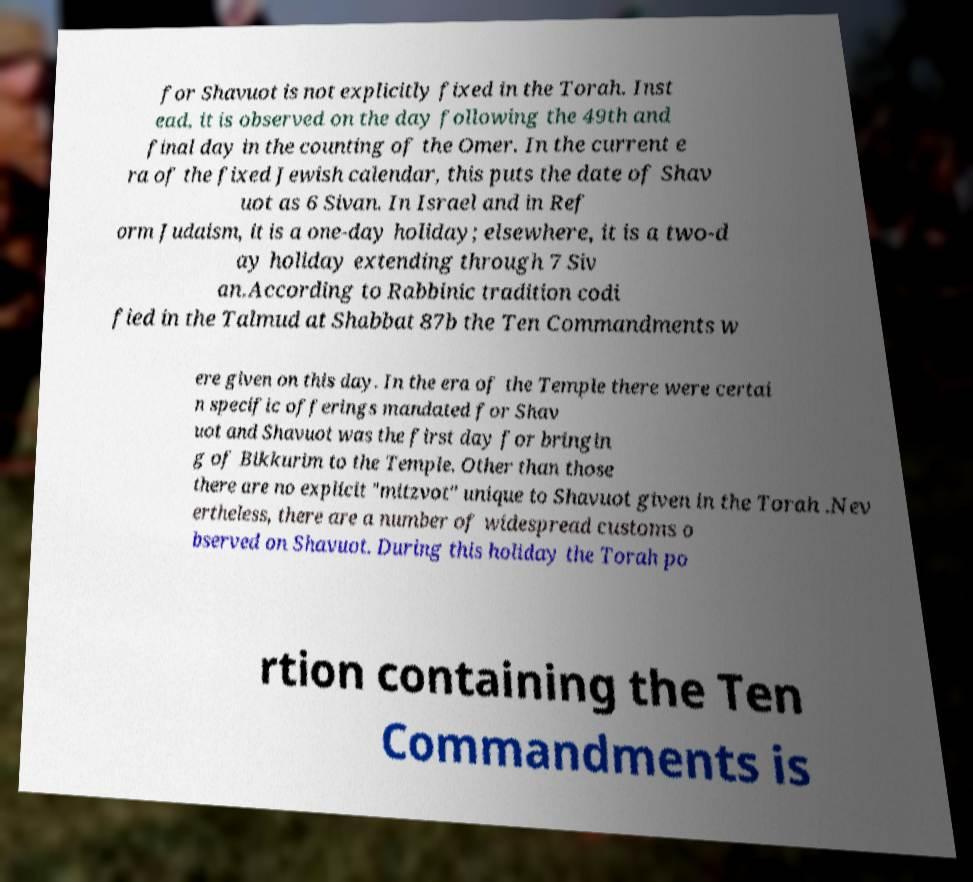Could you assist in decoding the text presented in this image and type it out clearly? for Shavuot is not explicitly fixed in the Torah. Inst ead, it is observed on the day following the 49th and final day in the counting of the Omer. In the current e ra of the fixed Jewish calendar, this puts the date of Shav uot as 6 Sivan. In Israel and in Ref orm Judaism, it is a one-day holiday; elsewhere, it is a two-d ay holiday extending through 7 Siv an.According to Rabbinic tradition codi fied in the Talmud at Shabbat 87b the Ten Commandments w ere given on this day. In the era of the Temple there were certai n specific offerings mandated for Shav uot and Shavuot was the first day for bringin g of Bikkurim to the Temple. Other than those there are no explicit "mitzvot" unique to Shavuot given in the Torah .Nev ertheless, there are a number of widespread customs o bserved on Shavuot. During this holiday the Torah po rtion containing the Ten Commandments is 